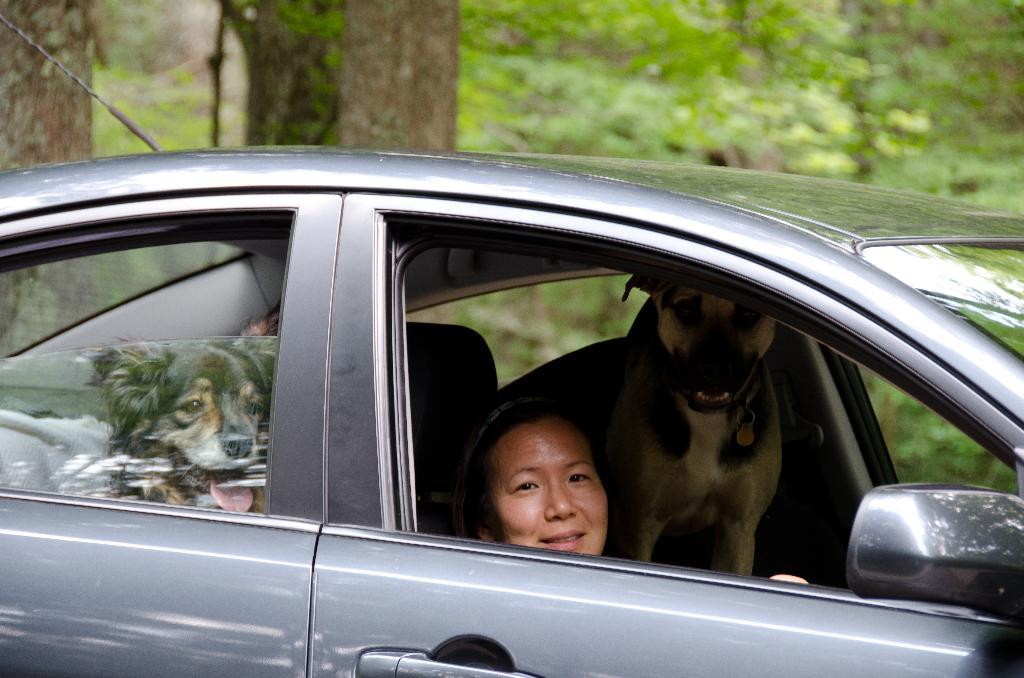Who is present in the image? There is a woman in the image. What is the woman doing in the image? The woman is sitting inside a car. What is the woman's facial expression in the image? The woman is smiling in the image. What other living beings are present in the car with the woman? There are dogs inside the car. What can be seen in the background of the image? There are trees visible at the back of the image. What type of haircut does the woman have in the image? There is no information about the woman's haircut in the image. Is there a note left on the car's windshield in the image? There is no mention of a note on the car's windshield in the provided facts. 